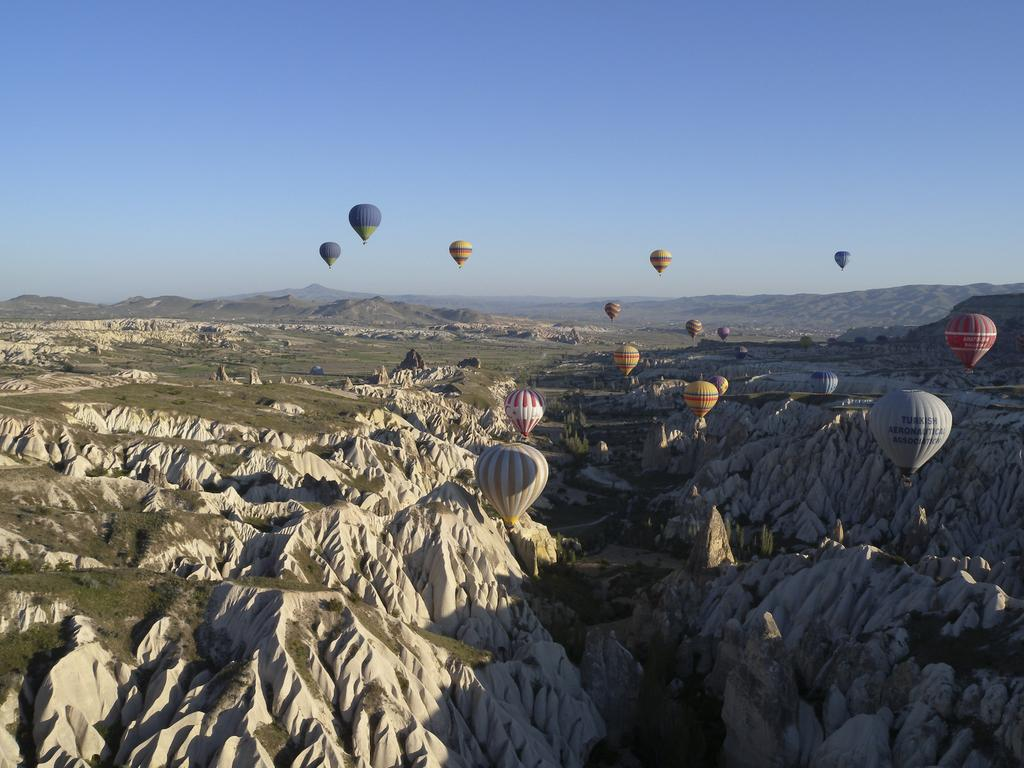What type of view is shown in the image? The image is an outside view. What geographical features can be seen at the bottom of the image? There are hills visible at the bottom of the image. What are the objects flying in the air in the image? There are parachutes flying in the air. What is visible at the top of the image? The sky is visible at the top of the image. What color is the copper used to build the brick wall in the image? There is no copper or brick wall present in the image. 